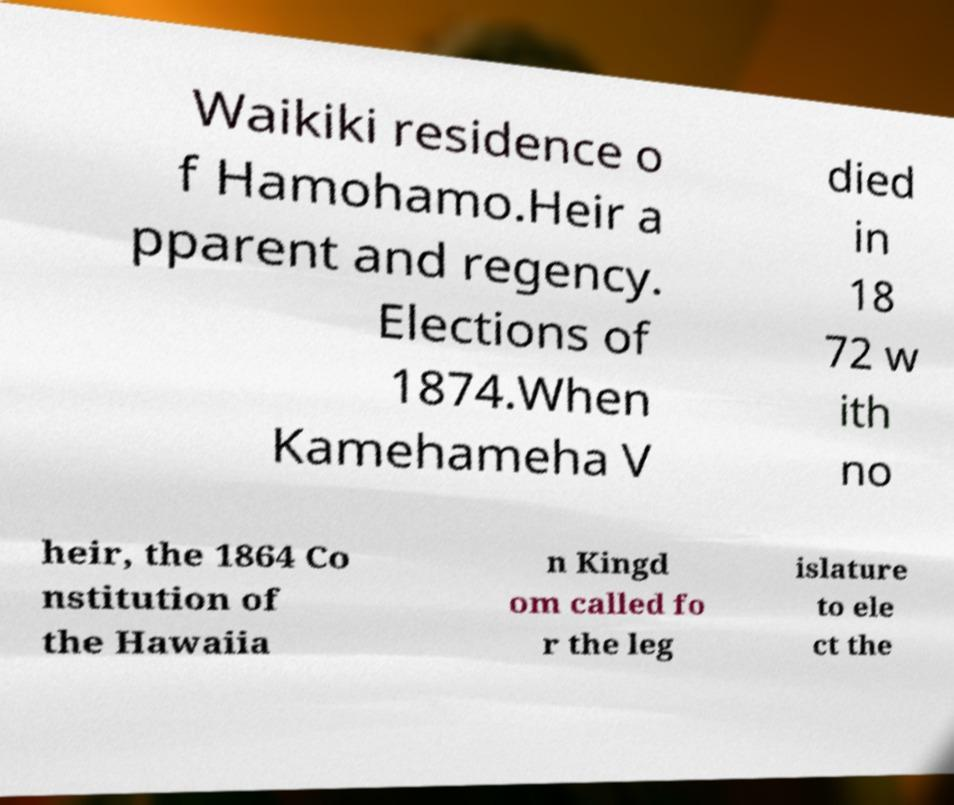Please identify and transcribe the text found in this image. Waikiki residence o f Hamohamo.Heir a pparent and regency. Elections of 1874.When Kamehameha V died in 18 72 w ith no heir, the 1864 Co nstitution of the Hawaiia n Kingd om called fo r the leg islature to ele ct the 